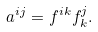Convert formula to latex. <formula><loc_0><loc_0><loc_500><loc_500>a ^ { i j } = f ^ { i k } f ^ { j } _ { k } .</formula> 